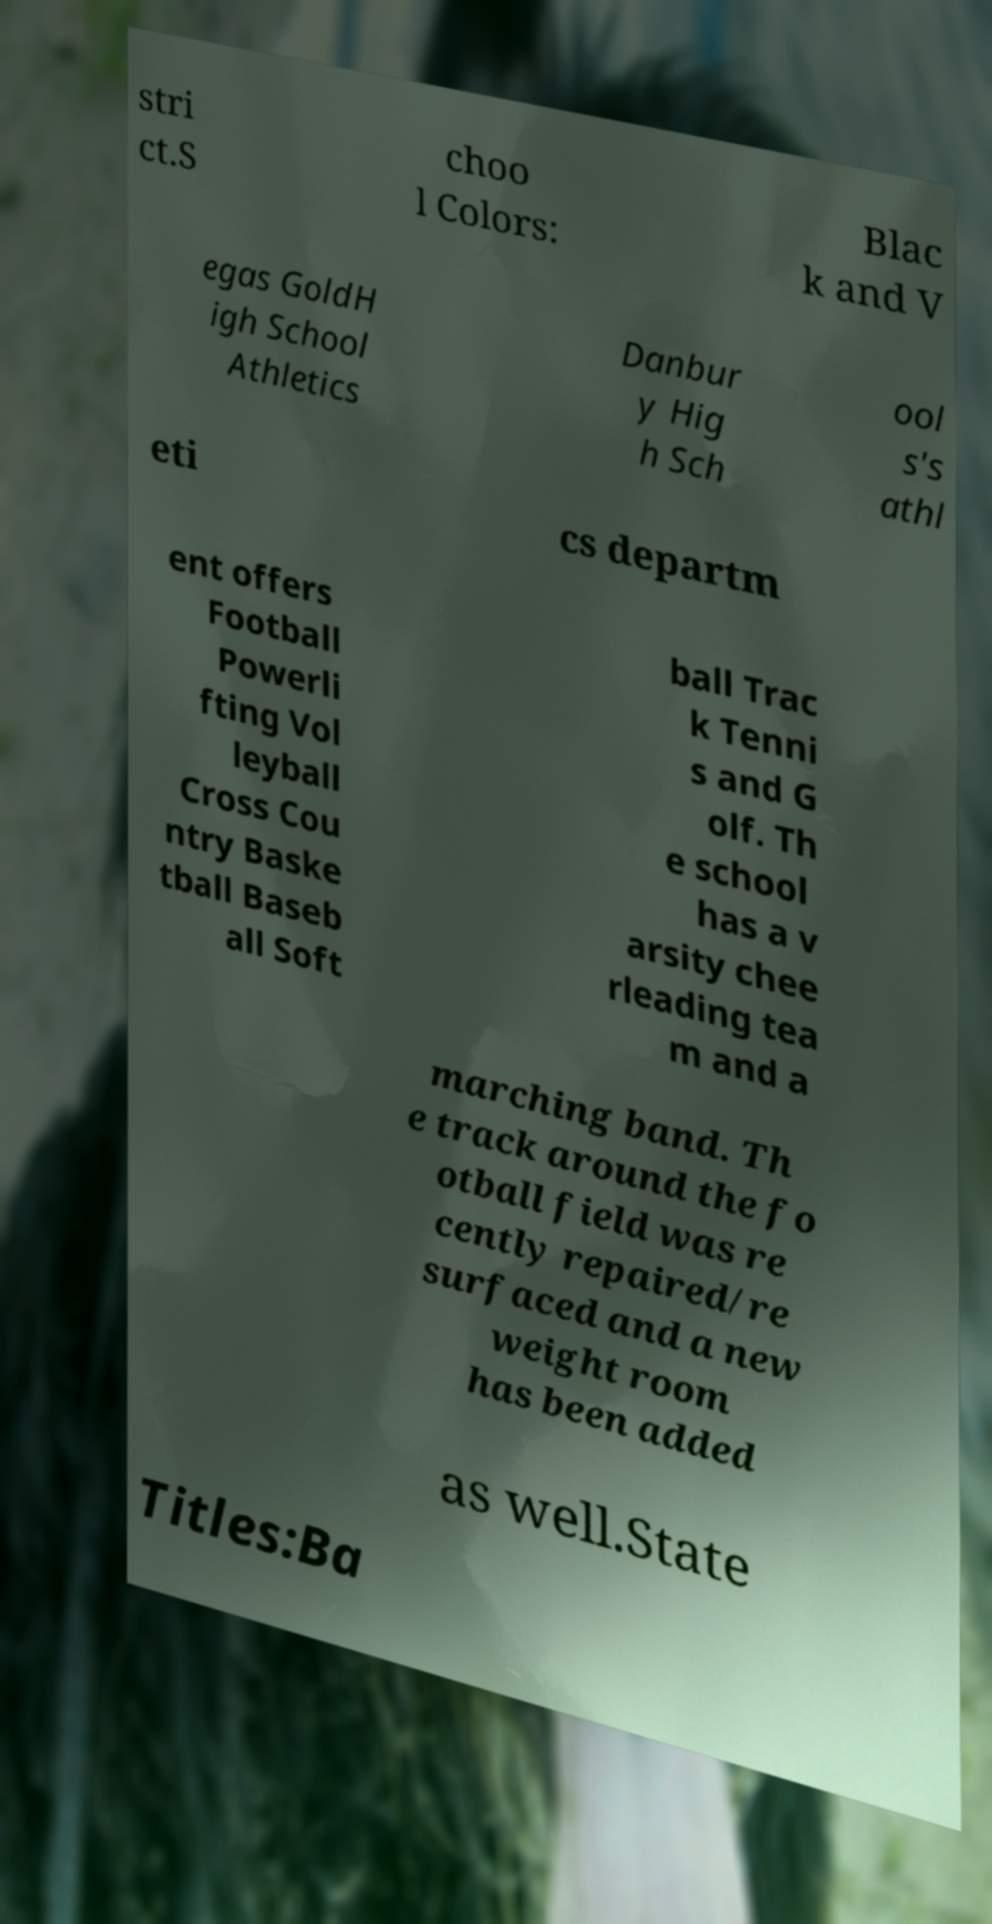Please identify and transcribe the text found in this image. stri ct.S choo l Colors: Blac k and V egas GoldH igh School Athletics Danbur y Hig h Sch ool s's athl eti cs departm ent offers Football Powerli fting Vol leyball Cross Cou ntry Baske tball Baseb all Soft ball Trac k Tenni s and G olf. Th e school has a v arsity chee rleading tea m and a marching band. Th e track around the fo otball field was re cently repaired/re surfaced and a new weight room has been added as well.State Titles:Ba 